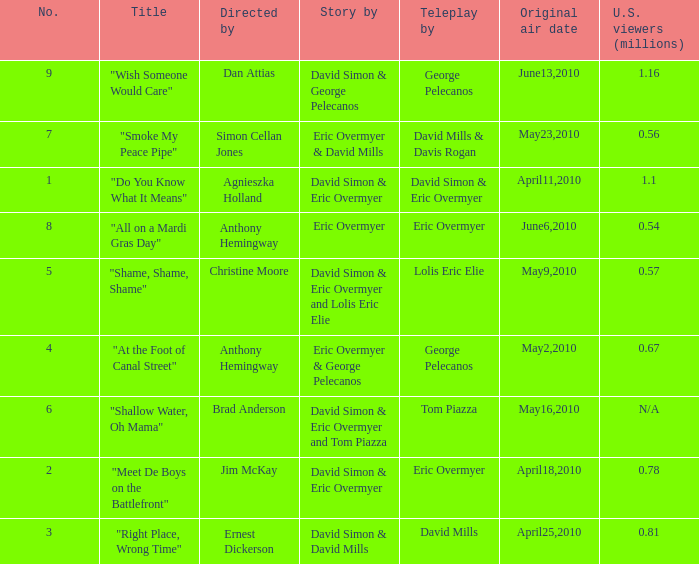Name the us viewers directed by christine moore 0.57. 